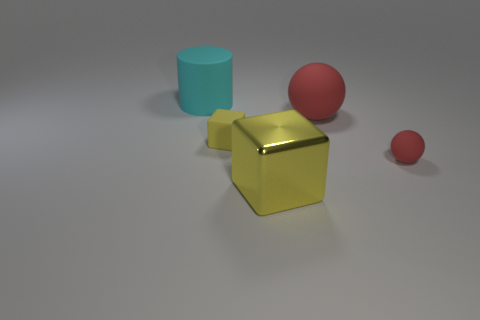How might the different textures represented in the image relate to each other? The textures in the image provide a comparative study of surfaces. The smoothness of the blue cylinder contrasts with the matte finish of the red spheres, suggesting variety in tactile sensation. The metallic sheen of the yellow cube adds a reflective quality that plays off the matte finishes, highlighting the visual and textural diversity present. 